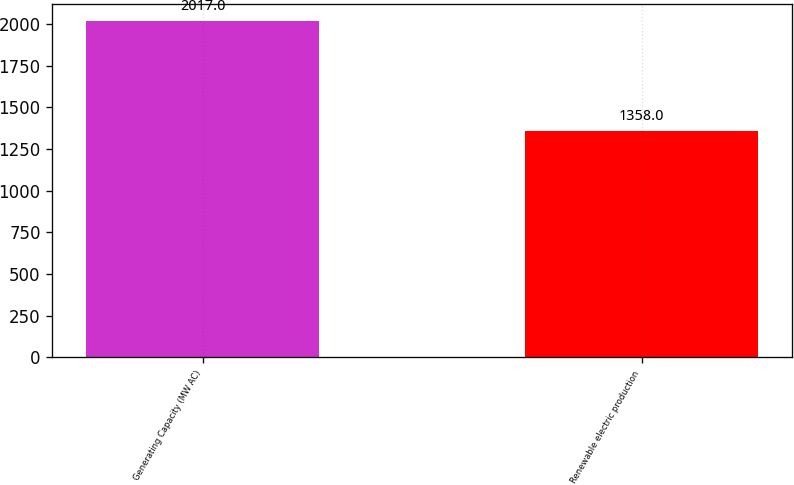Convert chart. <chart><loc_0><loc_0><loc_500><loc_500><bar_chart><fcel>Generating Capacity (MW AC)<fcel>Renewable electric production<nl><fcel>2017<fcel>1358<nl></chart> 